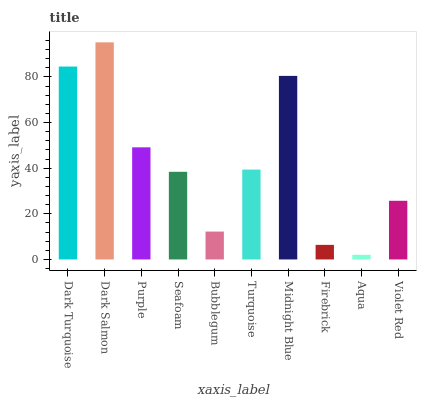Is Aqua the minimum?
Answer yes or no. Yes. Is Dark Salmon the maximum?
Answer yes or no. Yes. Is Purple the minimum?
Answer yes or no. No. Is Purple the maximum?
Answer yes or no. No. Is Dark Salmon greater than Purple?
Answer yes or no. Yes. Is Purple less than Dark Salmon?
Answer yes or no. Yes. Is Purple greater than Dark Salmon?
Answer yes or no. No. Is Dark Salmon less than Purple?
Answer yes or no. No. Is Turquoise the high median?
Answer yes or no. Yes. Is Seafoam the low median?
Answer yes or no. Yes. Is Purple the high median?
Answer yes or no. No. Is Bubblegum the low median?
Answer yes or no. No. 